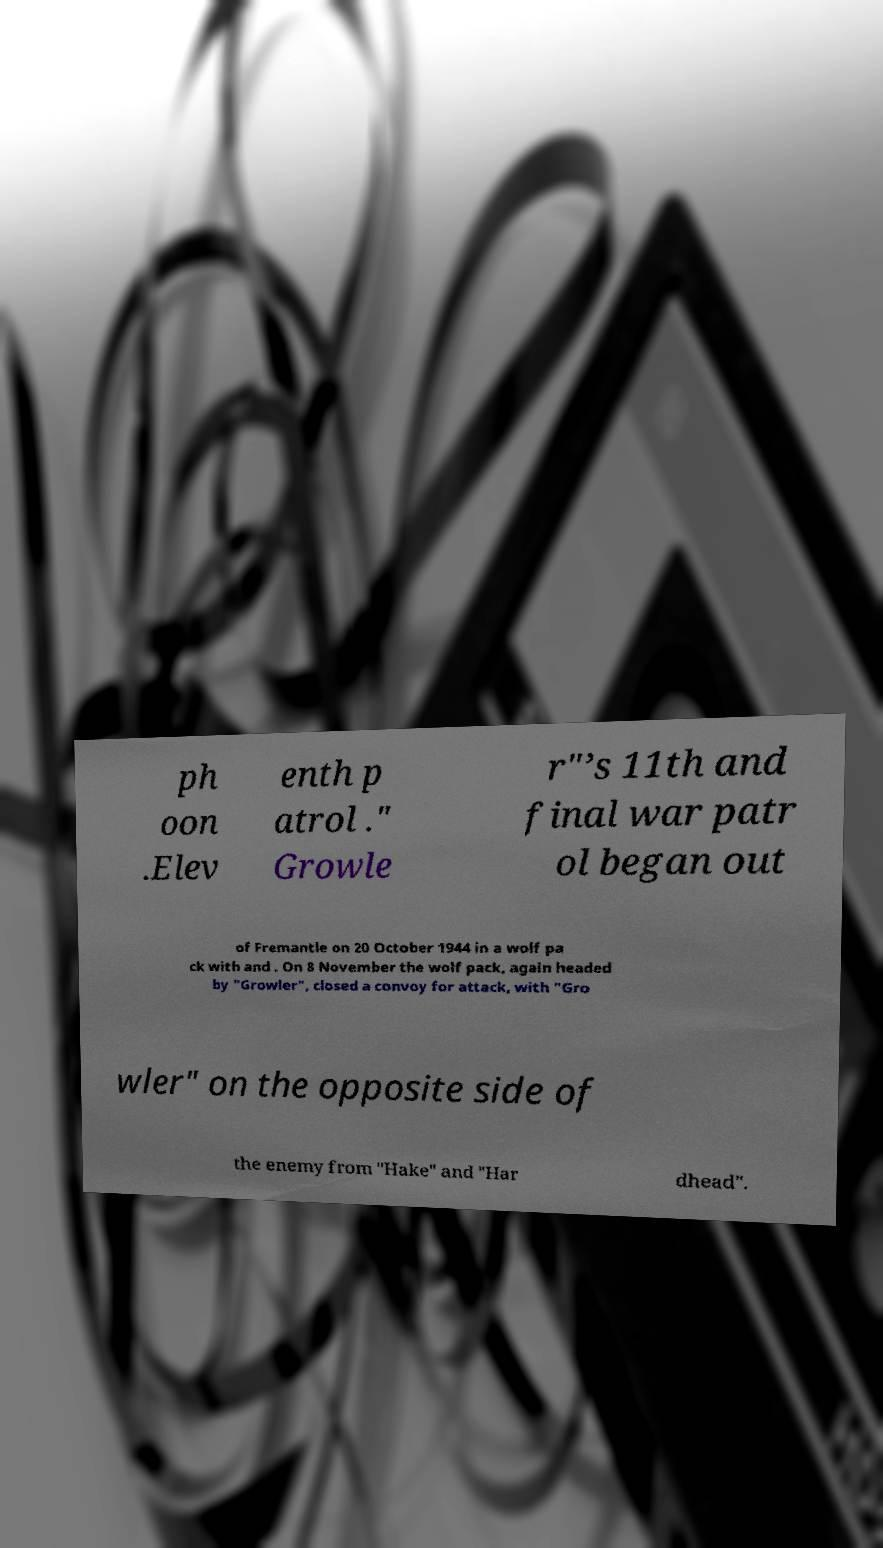I need the written content from this picture converted into text. Can you do that? ph oon .Elev enth p atrol ." Growle r"’s 11th and final war patr ol began out of Fremantle on 20 October 1944 in a wolf pa ck with and . On 8 November the wolf pack, again headed by "Growler", closed a convoy for attack, with "Gro wler" on the opposite side of the enemy from "Hake" and "Har dhead". 